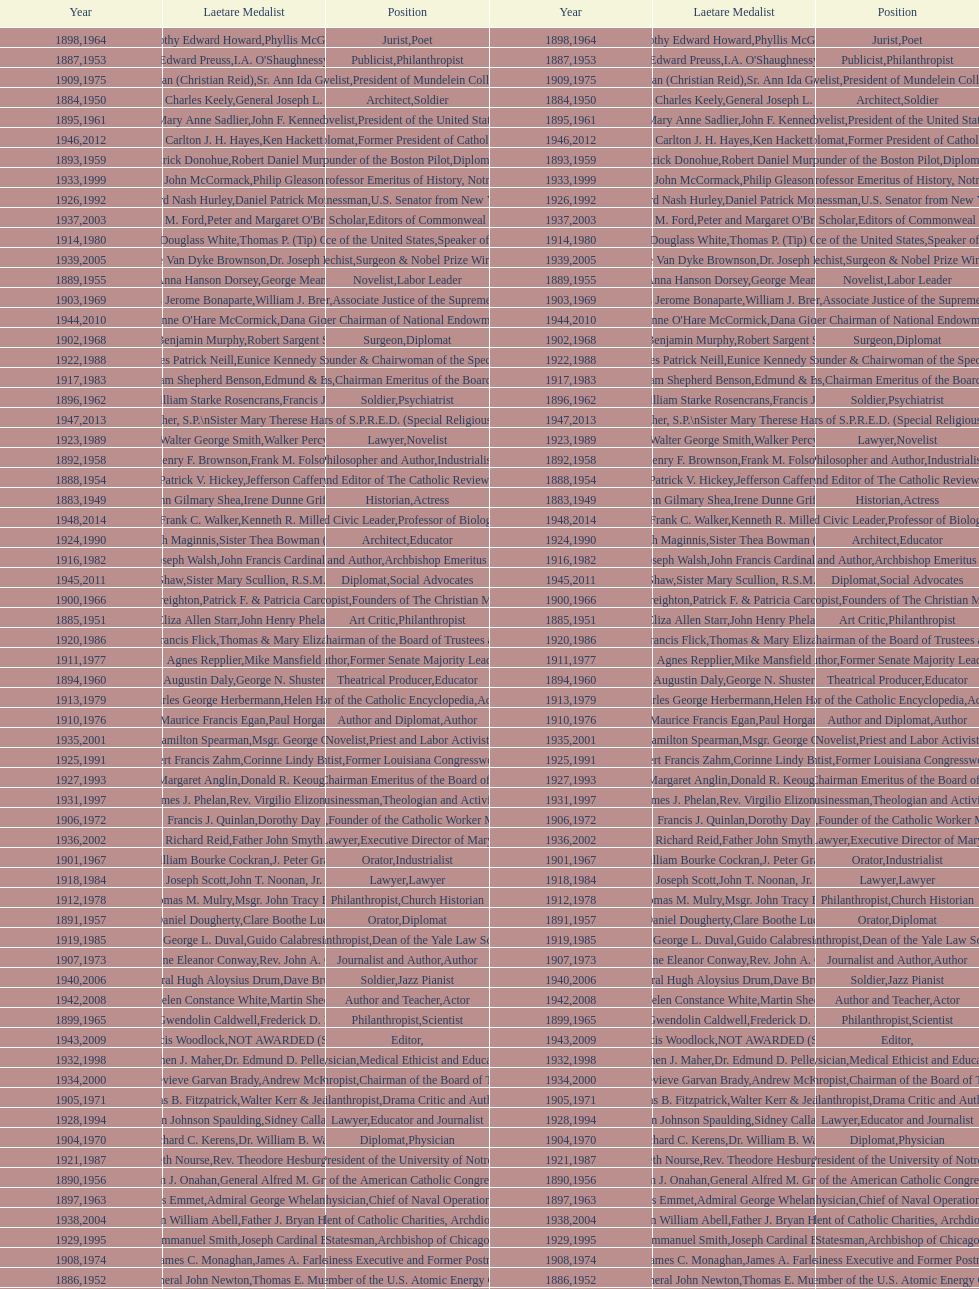How many lawyers have won the award between 1883 and 2014? 5. 